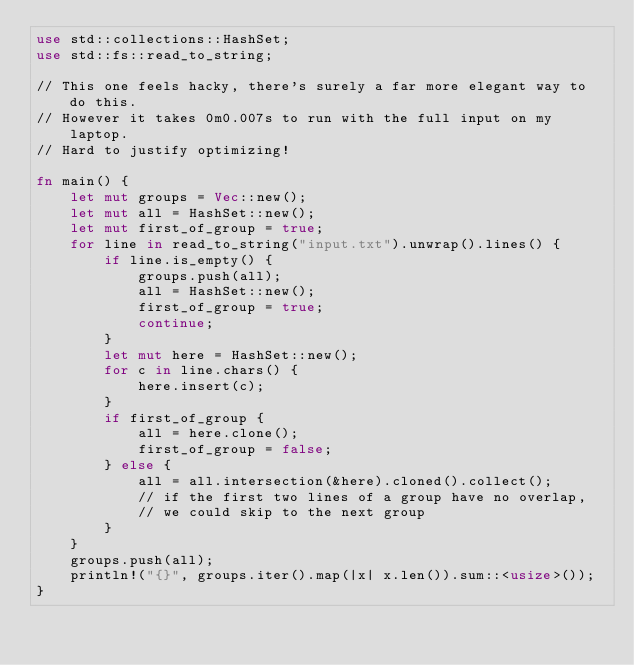Convert code to text. <code><loc_0><loc_0><loc_500><loc_500><_Rust_>use std::collections::HashSet;
use std::fs::read_to_string;

// This one feels hacky, there's surely a far more elegant way to do this.
// However it takes 0m0.007s to run with the full input on my laptop.
// Hard to justify optimizing!

fn main() {
    let mut groups = Vec::new();
    let mut all = HashSet::new();
    let mut first_of_group = true;
    for line in read_to_string("input.txt").unwrap().lines() {
        if line.is_empty() {
            groups.push(all);
            all = HashSet::new();
            first_of_group = true;
            continue;
        }
        let mut here = HashSet::new();
        for c in line.chars() {
            here.insert(c);
        }
        if first_of_group {
            all = here.clone();
            first_of_group = false;
        } else {
            all = all.intersection(&here).cloned().collect();
            // if the first two lines of a group have no overlap,
            // we could skip to the next group
        }
    }
    groups.push(all);
    println!("{}", groups.iter().map(|x| x.len()).sum::<usize>());
}
</code> 